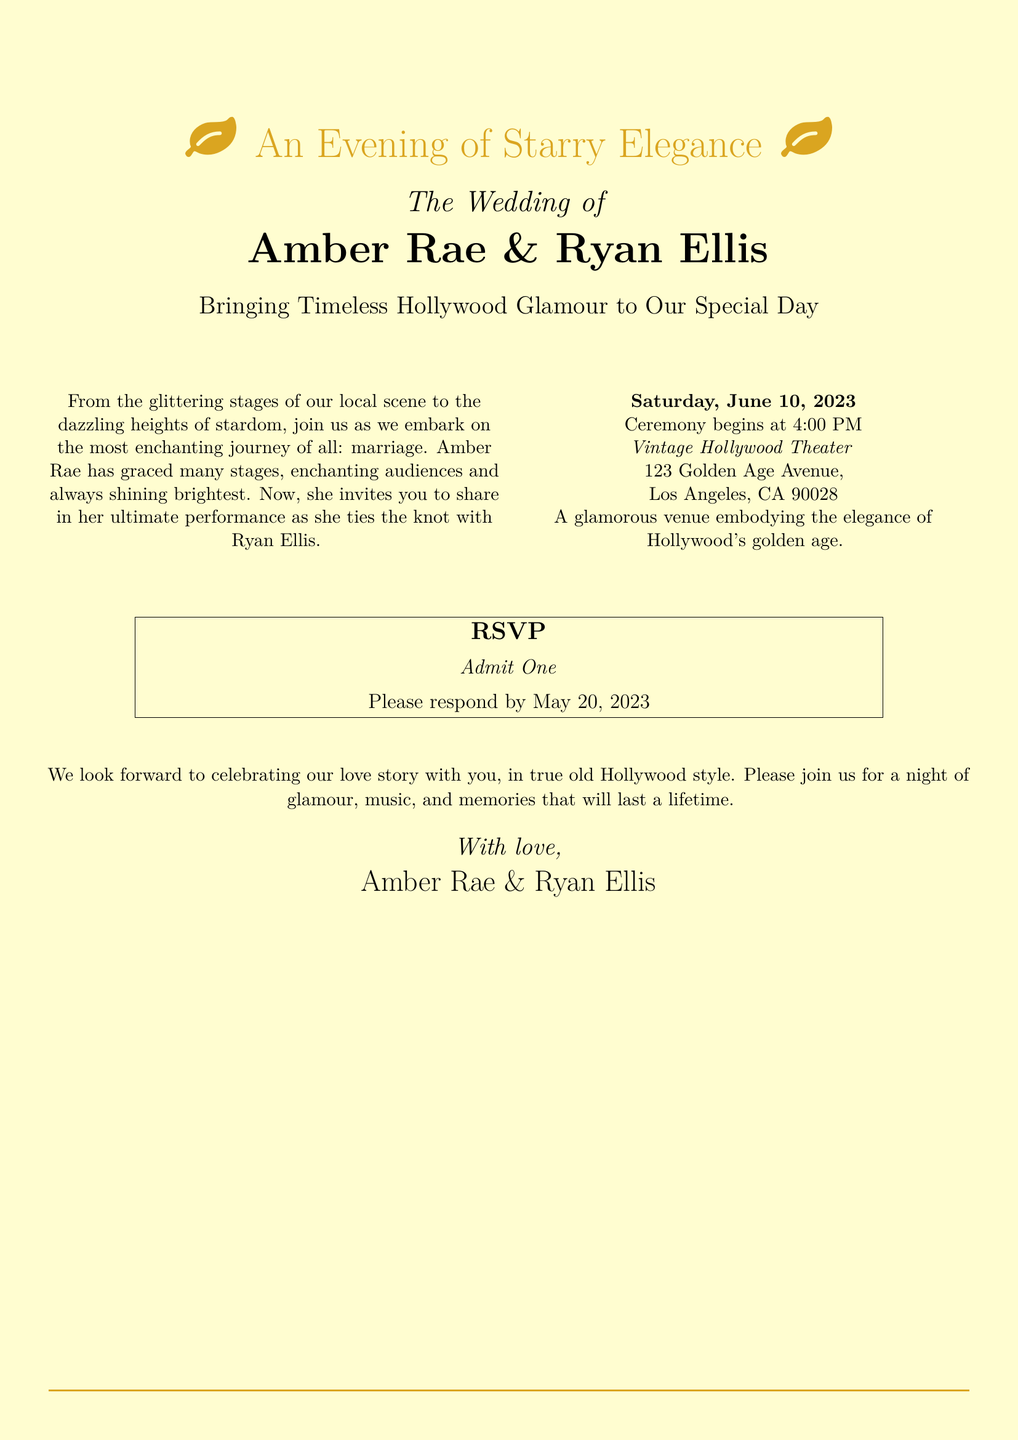What are the names of the couple? The document clearly states the names of the couple getting married as Amber Rae and Ryan Ellis.
Answer: Amber Rae & Ryan Ellis What is the wedding date? The invitation specifies the date of the ceremony, which is mentioned clearly.
Answer: June 10, 2023 What time does the ceremony begin? The invitation provides the time for the wedding ceremony.
Answer: 4:00 PM What is the location of the wedding? The document includes the venue's name and address, indicating where the event will take place.
Answer: Vintage Hollywood Theater, 123 Golden Age Avenue, Los Angeles, CA 90028 What is the RSVP deadline? The invitation states the date by which guests should respond to the invitation.
Answer: May 20, 2023 What style is the wedding inspired by? The document highlights the theme or style that the wedding draws inspiration from.
Answer: Vintage Hollywood Glamour Why is Amber Rae inviting guests? The text within the invitation explains the context of the invitation and Amber Rae's significance.
Answer: To share in her ultimate performance as she ties the knot What does the RSVP ticket say? The document features an RSVP ticket design that includes specific wording.
Answer: Admit One 